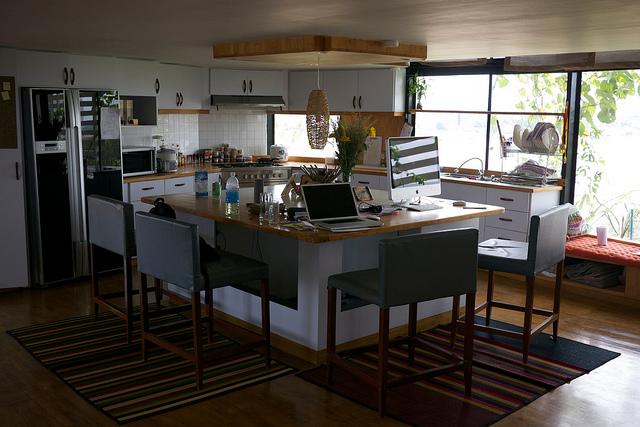What is on the table?
Write a very short answer. Laptop. How many chairs are in the image?
Keep it brief. 4. Is the laptop on or off?
Quick response, please. Off. Is this a cheap house to live in?
Keep it brief. No. How many people might live here?
Answer briefly. 4. What room is this?
Give a very brief answer. Kitchen. 